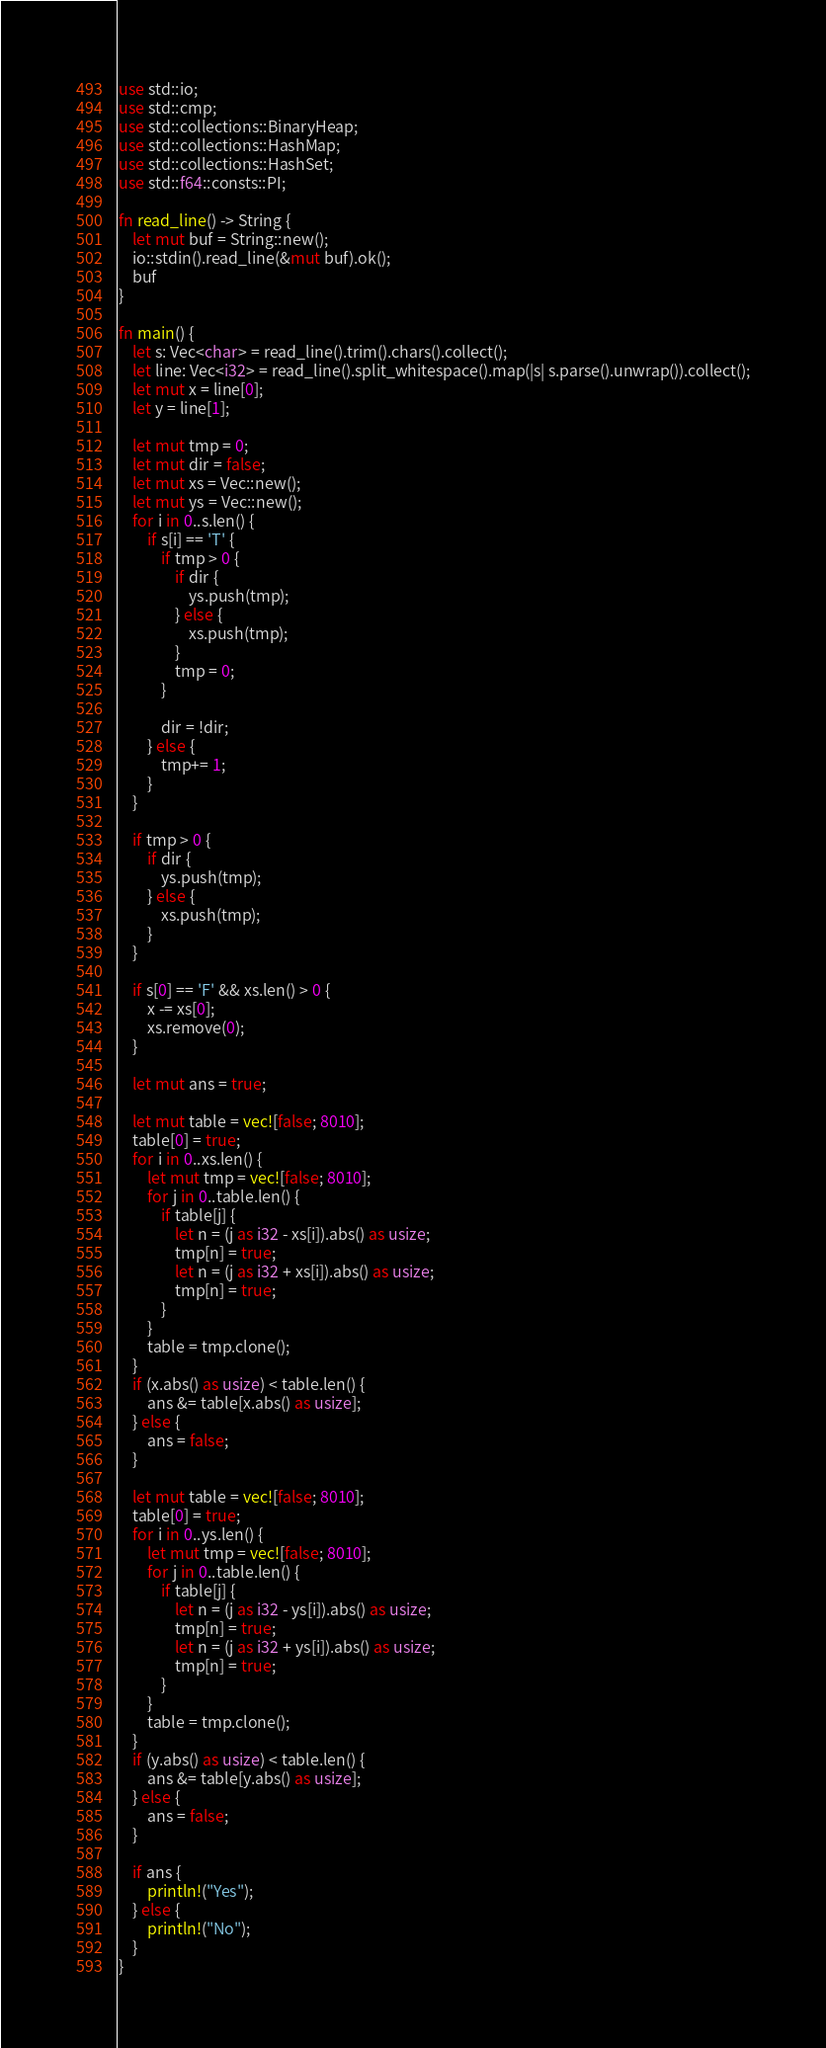Convert code to text. <code><loc_0><loc_0><loc_500><loc_500><_Rust_>use std::io;
use std::cmp;
use std::collections::BinaryHeap;
use std::collections::HashMap;
use std::collections::HashSet;
use std::f64::consts::PI;

fn read_line() -> String {
    let mut buf = String::new();
    io::stdin().read_line(&mut buf).ok();
    buf
}

fn main() {
    let s: Vec<char> = read_line().trim().chars().collect();
    let line: Vec<i32> = read_line().split_whitespace().map(|s| s.parse().unwrap()).collect();
    let mut x = line[0];
    let y = line[1];

    let mut tmp = 0;
    let mut dir = false;
    let mut xs = Vec::new();
    let mut ys = Vec::new();
    for i in 0..s.len() {
        if s[i] == 'T' {
            if tmp > 0 {
                if dir {
                    ys.push(tmp);
                } else {
                    xs.push(tmp);
                }
                tmp = 0;
            }

            dir = !dir;
        } else {
            tmp+= 1;
        }
    }

    if tmp > 0 {
        if dir {
            ys.push(tmp);
        } else {
            xs.push(tmp);
        }
    }

    if s[0] == 'F' && xs.len() > 0 {
        x -= xs[0];
        xs.remove(0);
    }

    let mut ans = true;

    let mut table = vec![false; 8010];
    table[0] = true;
    for i in 0..xs.len() {
        let mut tmp = vec![false; 8010];
        for j in 0..table.len() {
            if table[j] {
                let n = (j as i32 - xs[i]).abs() as usize;
                tmp[n] = true;
                let n = (j as i32 + xs[i]).abs() as usize;
                tmp[n] = true;
            }
        }
        table = tmp.clone();
    }
    if (x.abs() as usize) < table.len() {
        ans &= table[x.abs() as usize];
    } else {
        ans = false;
    }
    
    let mut table = vec![false; 8010];
    table[0] = true;
    for i in 0..ys.len() {
        let mut tmp = vec![false; 8010];
        for j in 0..table.len() {
            if table[j] {
                let n = (j as i32 - ys[i]).abs() as usize;
                tmp[n] = true;
                let n = (j as i32 + ys[i]).abs() as usize;
                tmp[n] = true;
            }
        }
        table = tmp.clone();
    }
    if (y.abs() as usize) < table.len() {
        ans &= table[y.abs() as usize];
    } else {
        ans = false;
    }

    if ans {
        println!("Yes");
    } else {
        println!("No");
    }
}
</code> 